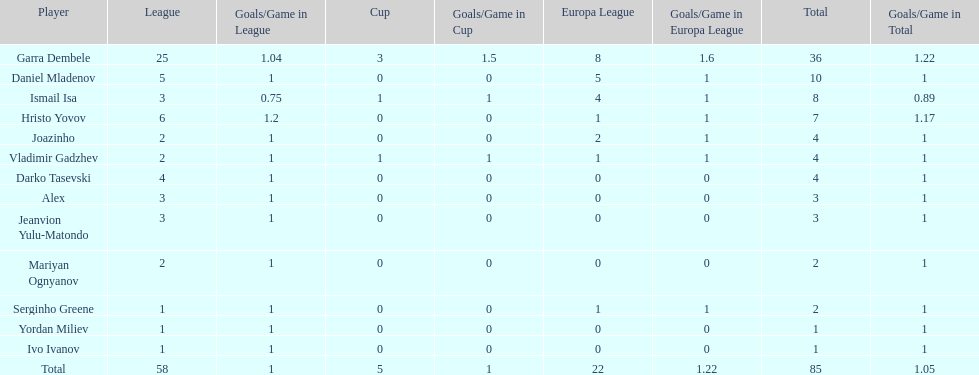Which players only achieved one goal? Serginho Greene, Yordan Miliev, Ivo Ivanov. 